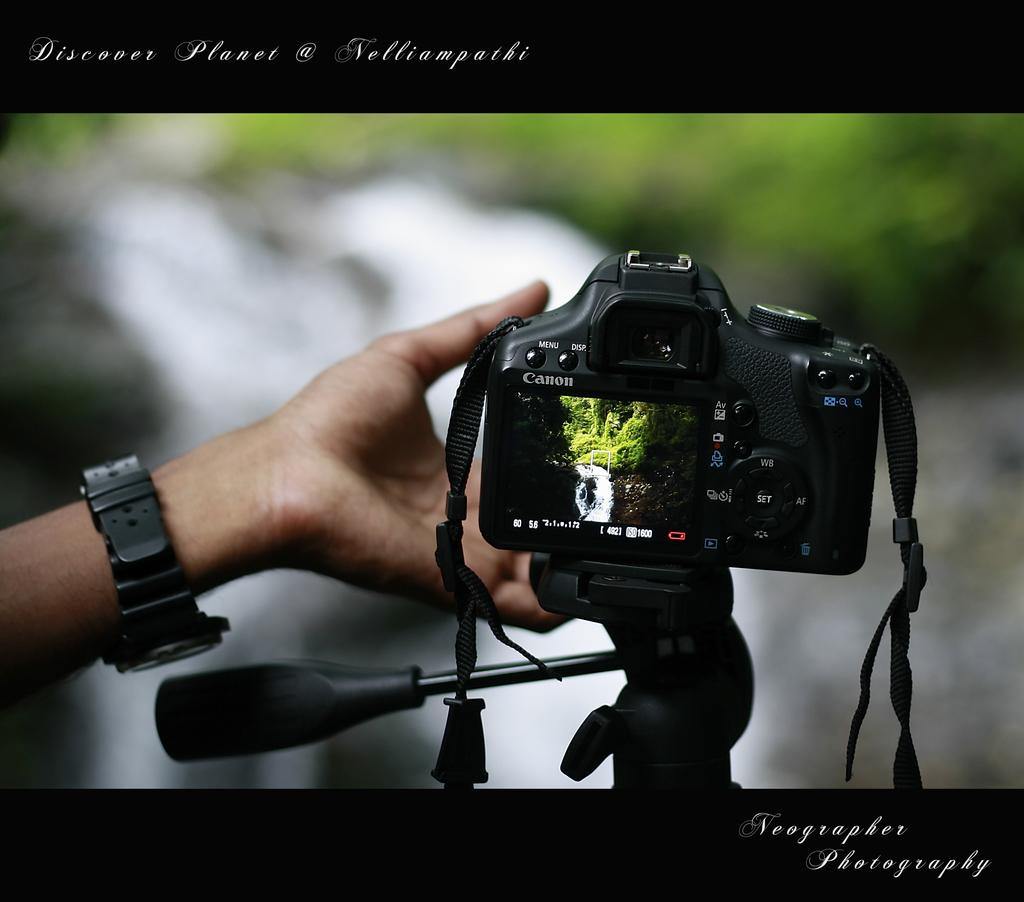Provide a one-sentence caption for the provided image. Neographer Photography has taken a photo of a hand taking a photo. 